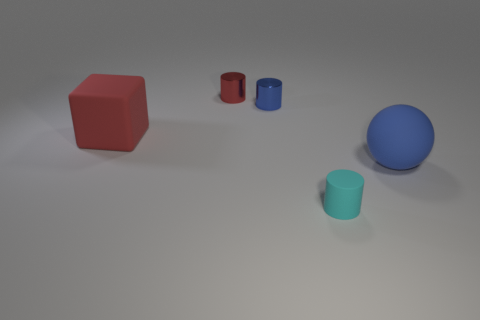Is the red shiny cylinder the same size as the ball?
Offer a very short reply. No. There is a cylinder that is both in front of the small red cylinder and behind the small rubber cylinder; what material is it?
Offer a very short reply. Metal. What number of tiny red objects are the same shape as the cyan matte thing?
Give a very brief answer. 1. There is a blue object that is to the left of the small rubber thing; what is it made of?
Provide a succinct answer. Metal. Are there fewer tiny rubber objects to the left of the tiny cyan cylinder than small green matte blocks?
Offer a very short reply. No. Is the tiny blue metal thing the same shape as the cyan matte object?
Your answer should be compact. Yes. Are there any other things that are the same shape as the large red rubber thing?
Your response must be concise. No. Are there any brown cylinders?
Make the answer very short. No. Is the shape of the small blue thing the same as the tiny object in front of the tiny blue metallic thing?
Offer a very short reply. Yes. What material is the blue thing that is left of the tiny cyan rubber object on the right side of the blue shiny object?
Your response must be concise. Metal. 